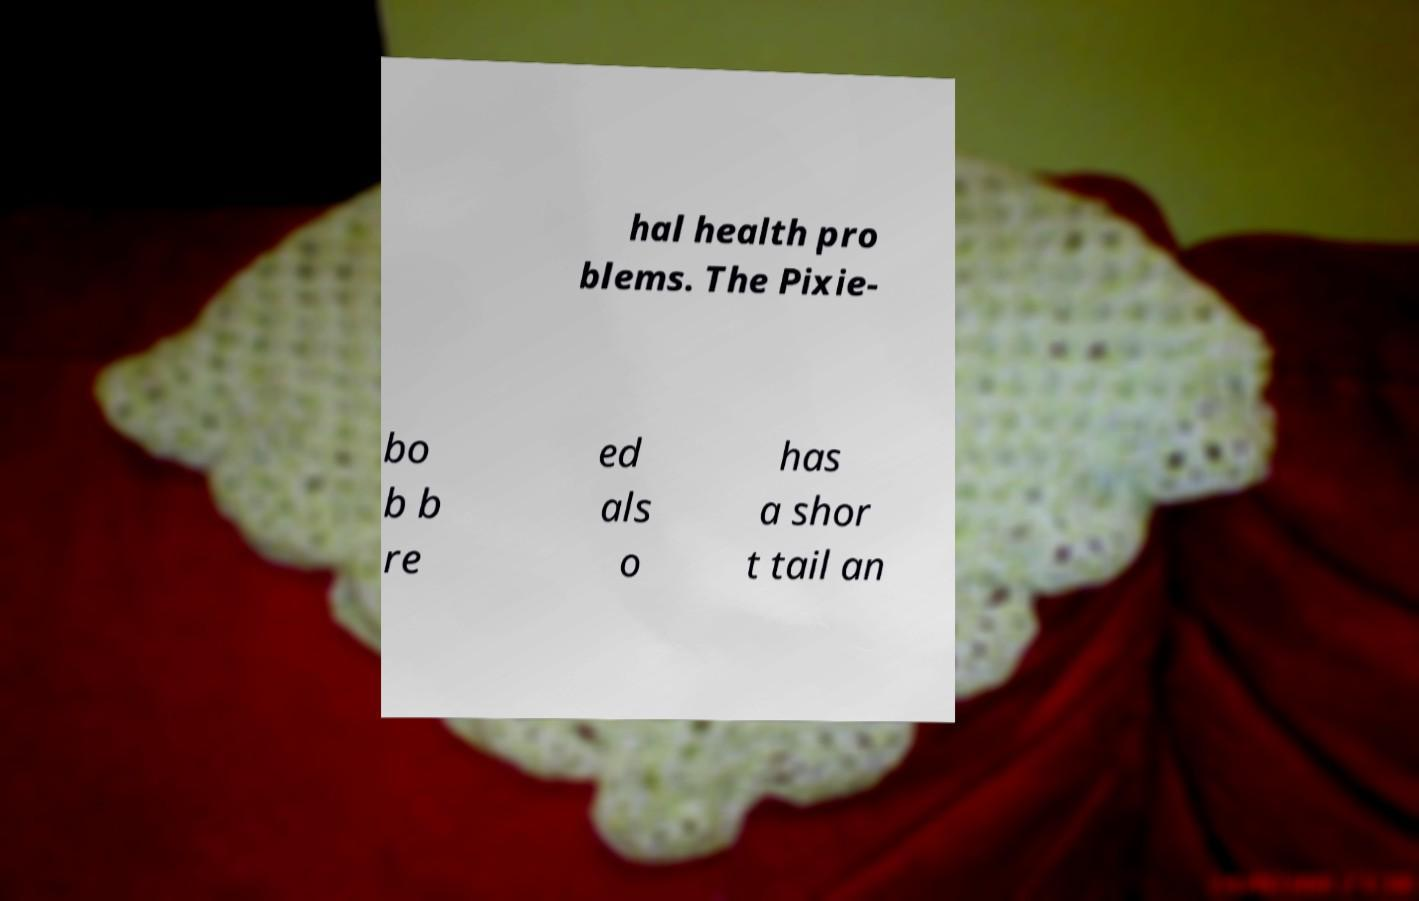Could you extract and type out the text from this image? hal health pro blems. The Pixie- bo b b re ed als o has a shor t tail an 